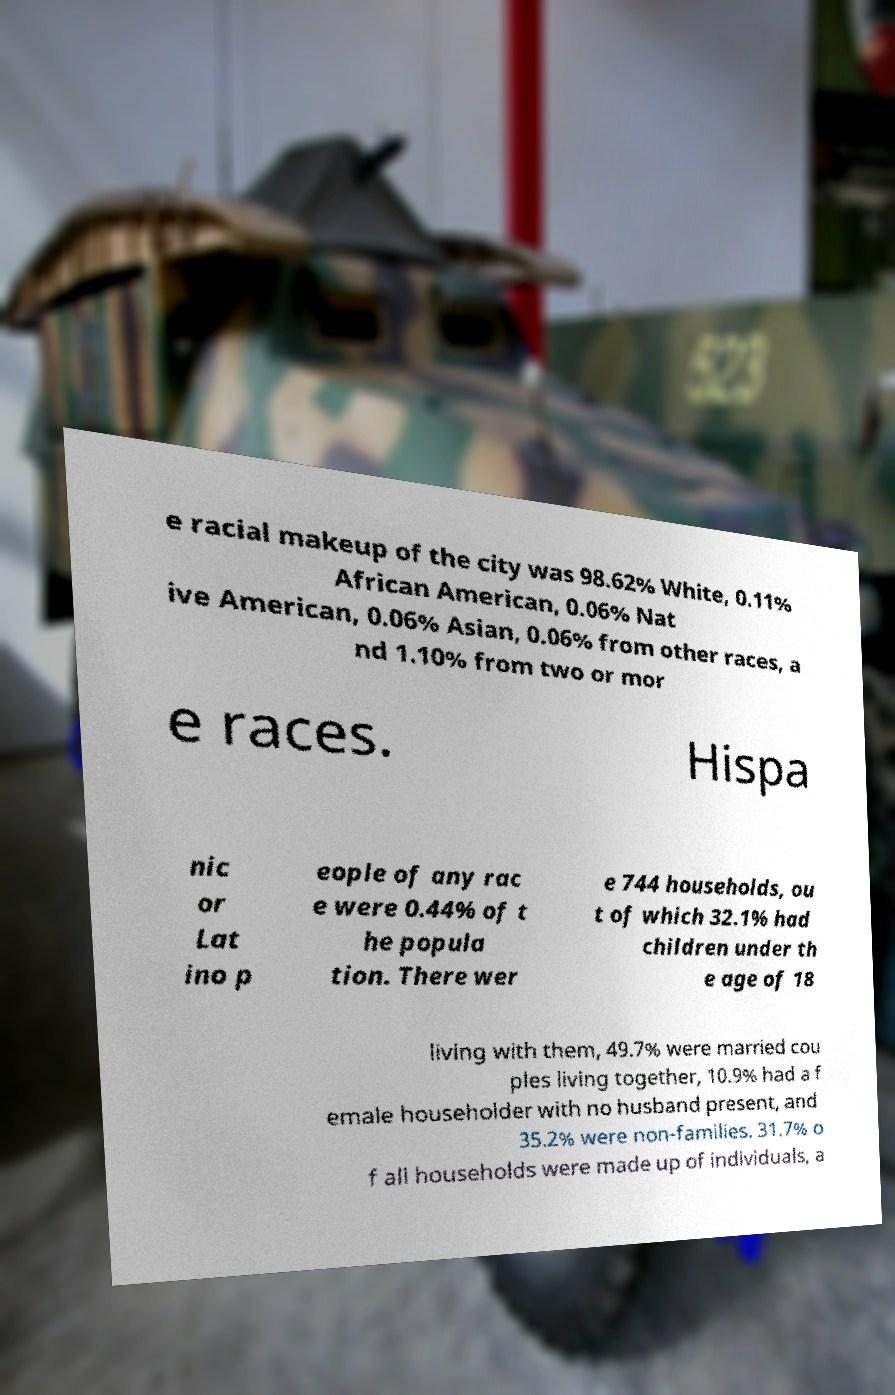Can you accurately transcribe the text from the provided image for me? e racial makeup of the city was 98.62% White, 0.11% African American, 0.06% Nat ive American, 0.06% Asian, 0.06% from other races, a nd 1.10% from two or mor e races. Hispa nic or Lat ino p eople of any rac e were 0.44% of t he popula tion. There wer e 744 households, ou t of which 32.1% had children under th e age of 18 living with them, 49.7% were married cou ples living together, 10.9% had a f emale householder with no husband present, and 35.2% were non-families. 31.7% o f all households were made up of individuals, a 